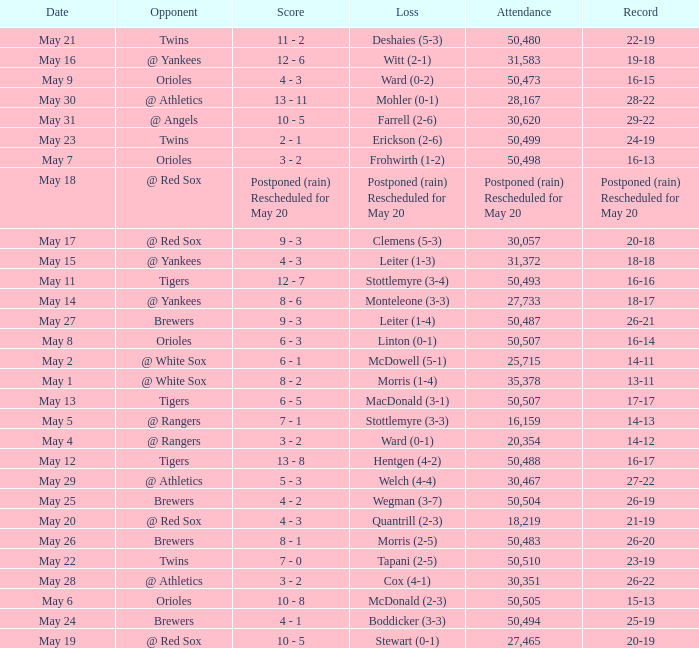What team did they lose to when they had a 28-22 record? Mohler (0-1). 